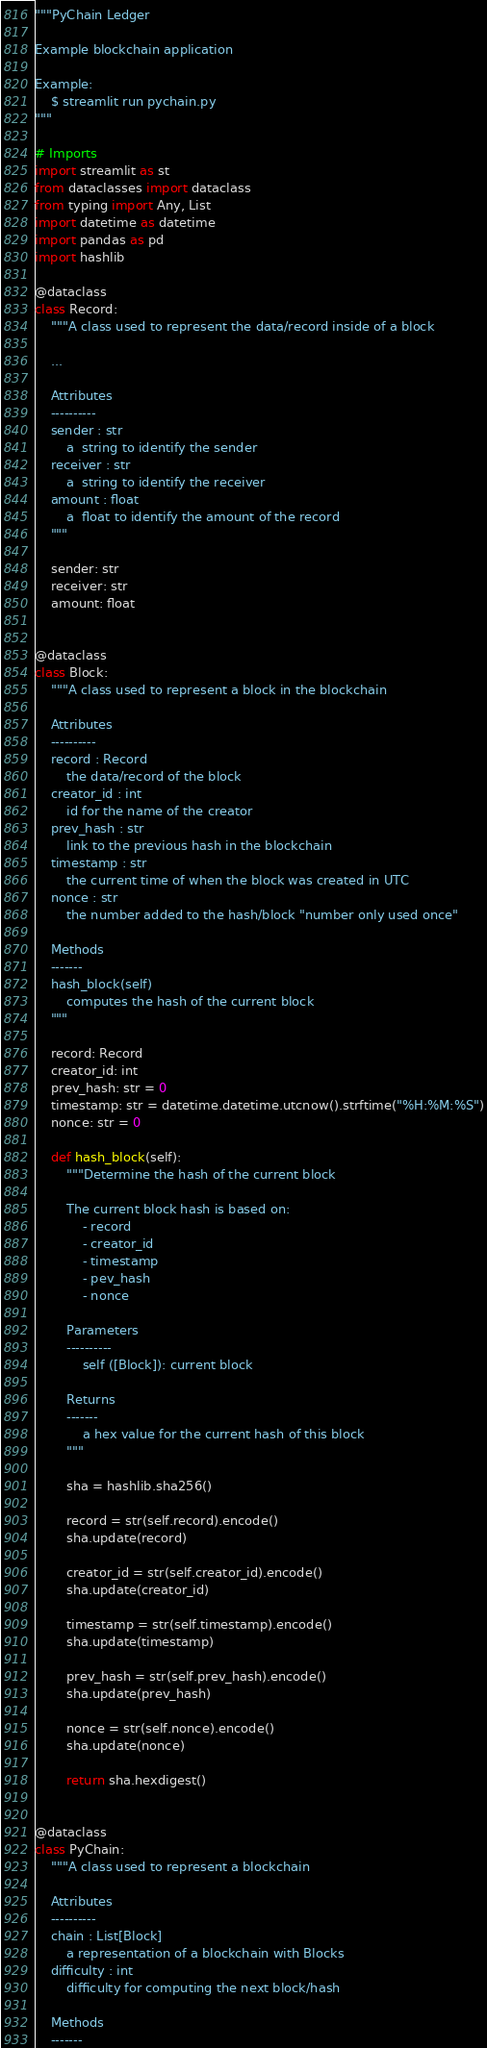<code> <loc_0><loc_0><loc_500><loc_500><_Python_>"""PyChain Ledger

Example blockchain application

Example:
    $ streamlit run pychain.py
"""

# Imports
import streamlit as st
from dataclasses import dataclass
from typing import Any, List
import datetime as datetime
import pandas as pd
import hashlib

@dataclass
class Record:
    """A class used to represent the data/record inside of a block

    ...

    Attributes
    ----------
    sender : str
        a  string to identify the sender
    receiver : str
        a  string to identify the receiver
    amount : float
        a  float to identify the amount of the record
    """

    sender: str
    receiver: str
    amount: float


@dataclass
class Block:
    """A class used to represent a block in the blockchain

    Attributes
    ----------
    record : Record
        the data/record of the block
    creator_id : int
        id for the name of the creator
    prev_hash : str
        link to the previous hash in the blockchain
    timestamp : str
        the current time of when the block was created in UTC
    nonce : str
        the number added to the hash/block "number only used once"

    Methods
    -------
    hash_block(self)
        computes the hash of the current block
    """

    record: Record
    creator_id: int
    prev_hash: str = 0
    timestamp: str = datetime.datetime.utcnow().strftime("%H:%M:%S")
    nonce: str = 0

    def hash_block(self):
        """Determine the hash of the current block

        The current block hash is based on:
            - record
            - creator_id
            - timestamp
            - pev_hash
            - nonce

        Parameters
        ----------
            self ([Block]): current block

        Returns
        -------
            a hex value for the current hash of this block
        """

        sha = hashlib.sha256()

        record = str(self.record).encode()
        sha.update(record)

        creator_id = str(self.creator_id).encode()
        sha.update(creator_id)

        timestamp = str(self.timestamp).encode()
        sha.update(timestamp)

        prev_hash = str(self.prev_hash).encode()
        sha.update(prev_hash)

        nonce = str(self.nonce).encode()
        sha.update(nonce)

        return sha.hexdigest()


@dataclass
class PyChain:
    """A class used to represent a blockchain

    Attributes
    ----------
    chain : List[Block]
        a representation of a blockchain with Blocks
    difficulty : int
        difficulty for computing the next block/hash

    Methods
    -------</code> 